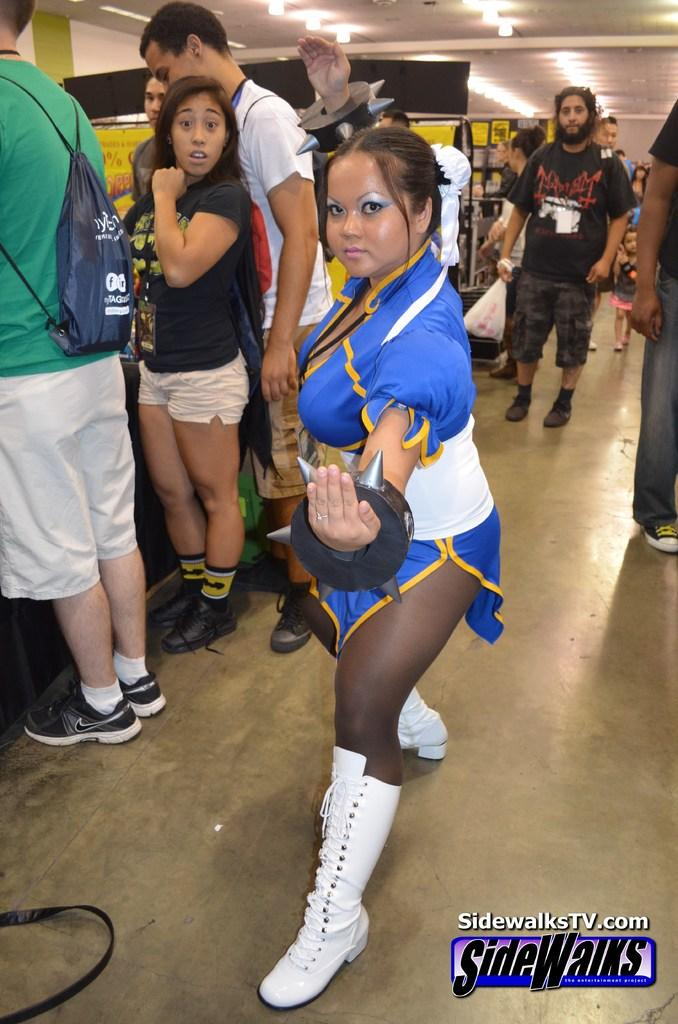How many people are in the image? There are people in the image, but the exact number is not specified. What is located behind the people in the image? There is a wall in the image. What can be seen illuminating the scene in the image? There are lights in the image. Can you describe the woman standing in the front of the image? The woman standing in the front of the image is wearing a blue color dress and white color shoes. What month is depicted in the image? There is no indication of a specific month in the image. Can you describe the stone structure in the image? There is no stone structure present in the image. 